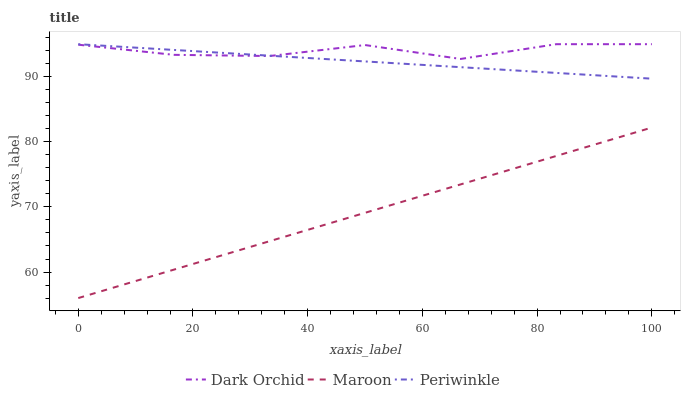Does Maroon have the minimum area under the curve?
Answer yes or no. Yes. Does Dark Orchid have the maximum area under the curve?
Answer yes or no. Yes. Does Dark Orchid have the minimum area under the curve?
Answer yes or no. No. Does Maroon have the maximum area under the curve?
Answer yes or no. No. Is Maroon the smoothest?
Answer yes or no. Yes. Is Dark Orchid the roughest?
Answer yes or no. Yes. Is Dark Orchid the smoothest?
Answer yes or no. No. Is Maroon the roughest?
Answer yes or no. No. Does Maroon have the lowest value?
Answer yes or no. Yes. Does Dark Orchid have the lowest value?
Answer yes or no. No. Does Dark Orchid have the highest value?
Answer yes or no. Yes. Does Maroon have the highest value?
Answer yes or no. No. Is Maroon less than Dark Orchid?
Answer yes or no. Yes. Is Dark Orchid greater than Maroon?
Answer yes or no. Yes. Does Dark Orchid intersect Periwinkle?
Answer yes or no. Yes. Is Dark Orchid less than Periwinkle?
Answer yes or no. No. Is Dark Orchid greater than Periwinkle?
Answer yes or no. No. Does Maroon intersect Dark Orchid?
Answer yes or no. No. 